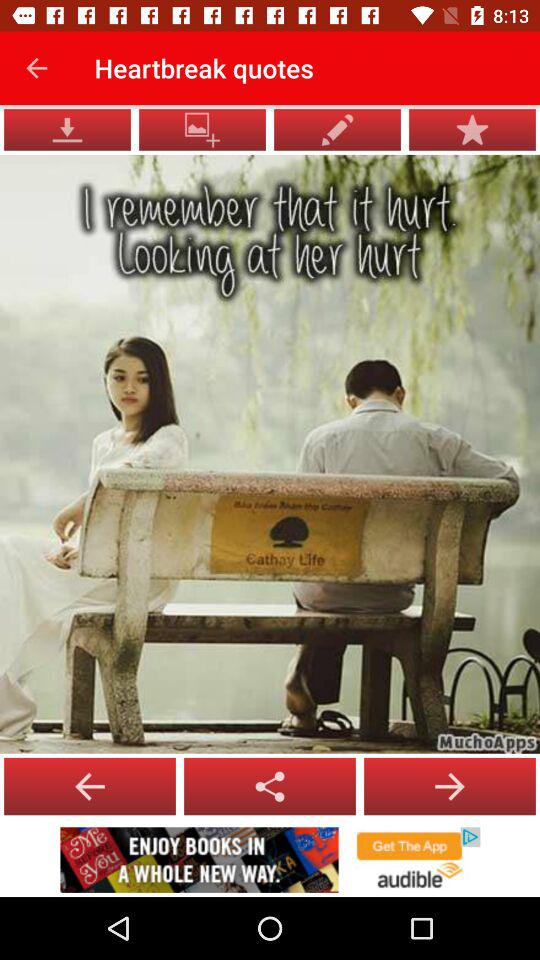What is the app name? The app names are "MuchoApps" and "audible". 